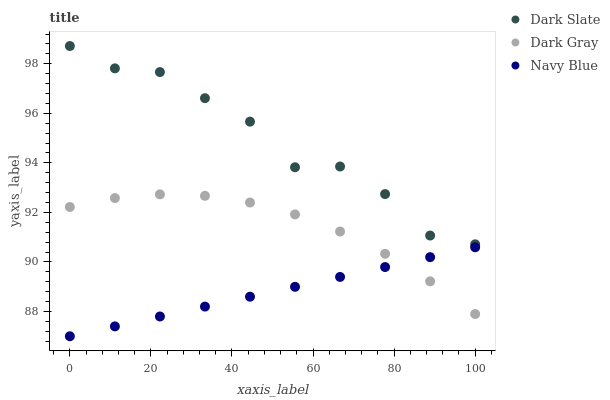Does Navy Blue have the minimum area under the curve?
Answer yes or no. Yes. Does Dark Slate have the maximum area under the curve?
Answer yes or no. Yes. Does Dark Slate have the minimum area under the curve?
Answer yes or no. No. Does Navy Blue have the maximum area under the curve?
Answer yes or no. No. Is Navy Blue the smoothest?
Answer yes or no. Yes. Is Dark Slate the roughest?
Answer yes or no. Yes. Is Dark Slate the smoothest?
Answer yes or no. No. Is Navy Blue the roughest?
Answer yes or no. No. Does Navy Blue have the lowest value?
Answer yes or no. Yes. Does Dark Slate have the lowest value?
Answer yes or no. No. Does Dark Slate have the highest value?
Answer yes or no. Yes. Does Navy Blue have the highest value?
Answer yes or no. No. Is Dark Gray less than Dark Slate?
Answer yes or no. Yes. Is Dark Slate greater than Dark Gray?
Answer yes or no. Yes. Does Navy Blue intersect Dark Gray?
Answer yes or no. Yes. Is Navy Blue less than Dark Gray?
Answer yes or no. No. Is Navy Blue greater than Dark Gray?
Answer yes or no. No. Does Dark Gray intersect Dark Slate?
Answer yes or no. No. 